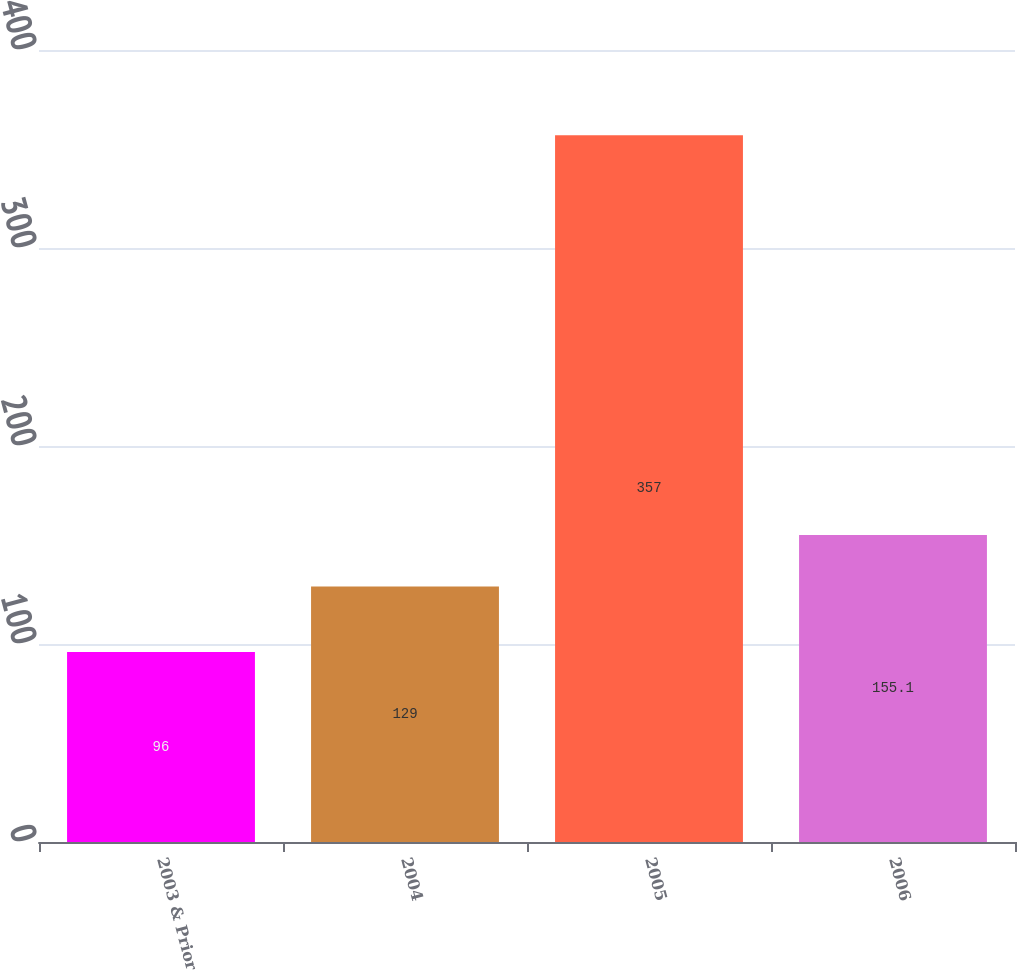Convert chart. <chart><loc_0><loc_0><loc_500><loc_500><bar_chart><fcel>2003 & Prior<fcel>2004<fcel>2005<fcel>2006<nl><fcel>96<fcel>129<fcel>357<fcel>155.1<nl></chart> 